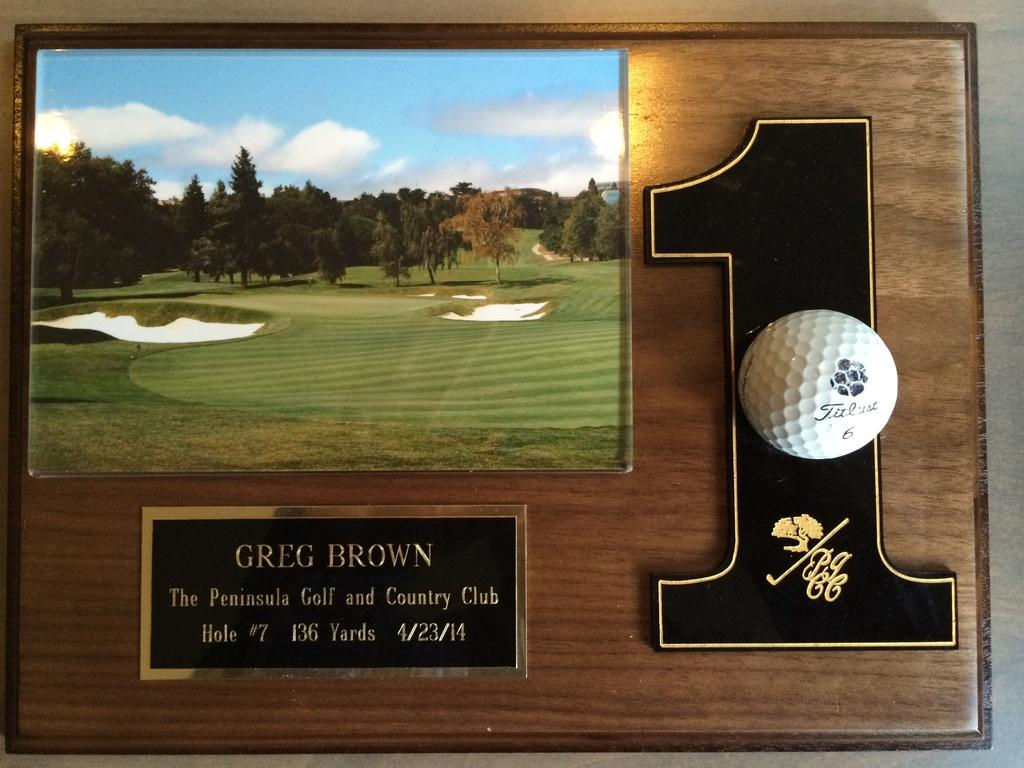Provide a one-sentence caption for the provided image. a plaque with the number 1 on it. 